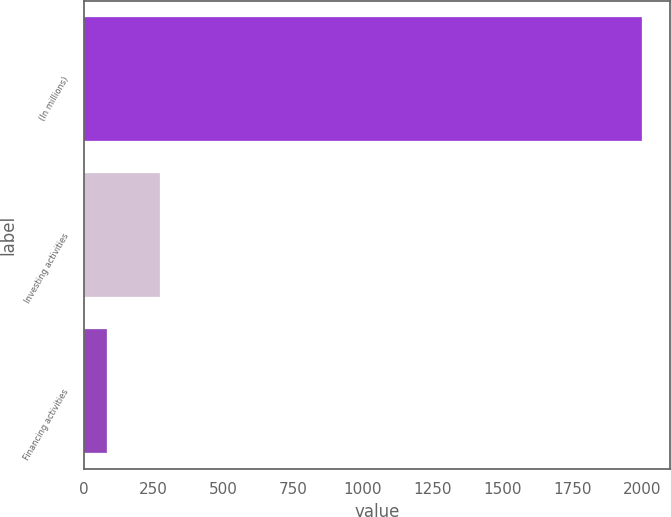Convert chart to OTSL. <chart><loc_0><loc_0><loc_500><loc_500><bar_chart><fcel>(In millions)<fcel>Investing activities<fcel>Financing activities<nl><fcel>2002<fcel>273.64<fcel>81.6<nl></chart> 